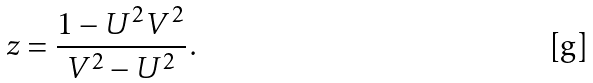<formula> <loc_0><loc_0><loc_500><loc_500>z = \frac { 1 - U ^ { 2 } V ^ { 2 } } { V ^ { 2 } - U ^ { 2 } } \, .</formula> 